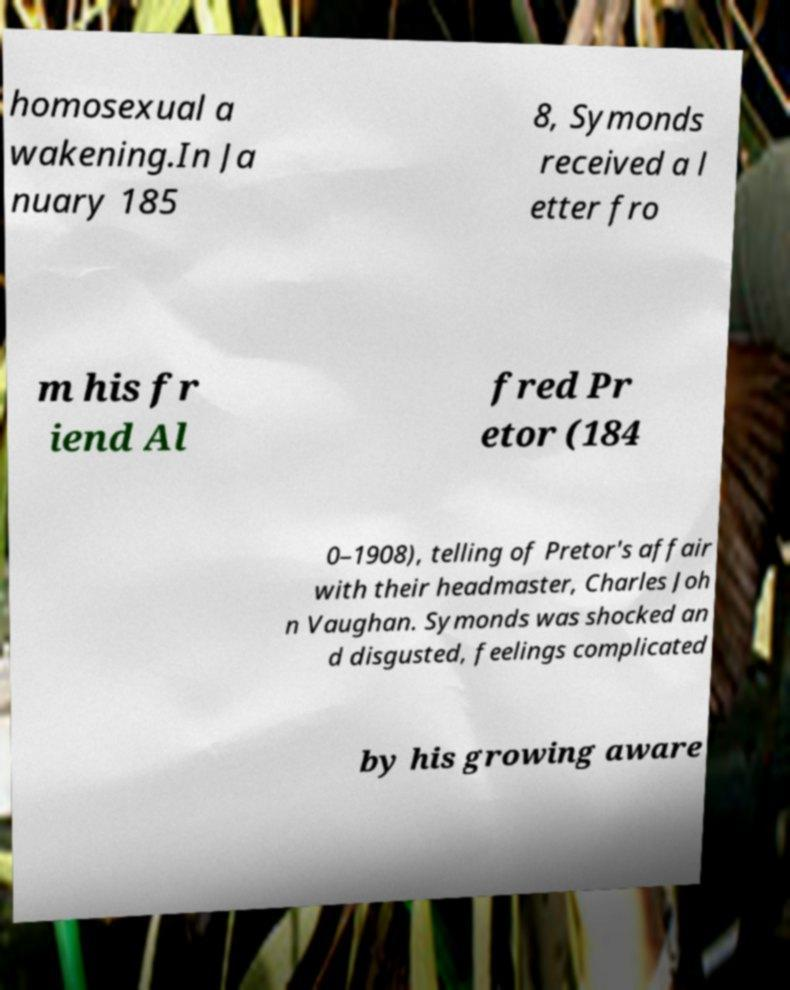For documentation purposes, I need the text within this image transcribed. Could you provide that? homosexual a wakening.In Ja nuary 185 8, Symonds received a l etter fro m his fr iend Al fred Pr etor (184 0–1908), telling of Pretor's affair with their headmaster, Charles Joh n Vaughan. Symonds was shocked an d disgusted, feelings complicated by his growing aware 